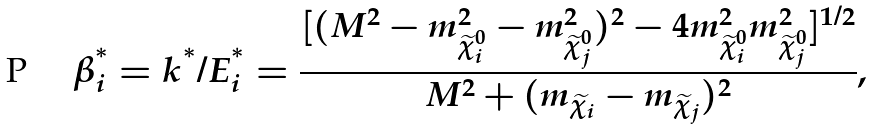<formula> <loc_0><loc_0><loc_500><loc_500>\beta _ { i } ^ { ^ { * } } = { k ^ { ^ { * } } } / { E _ { i } ^ { ^ { * } } } = \frac { [ ( M ^ { 2 } - m _ { \widetilde { \chi } _ { i } ^ { 0 } } ^ { 2 } - m _ { \widetilde { \chi } _ { j } ^ { 0 } } ^ { 2 } ) ^ { 2 } - 4 m _ { \widetilde { \chi } _ { i } ^ { 0 } } ^ { 2 } m _ { \widetilde { \chi } _ { j } ^ { 0 } } ^ { 2 } ] ^ { 1 / 2 } } { M ^ { 2 } + ( m _ { \widetilde { \chi } _ { i } } - m _ { \widetilde { \chi } _ { j } } ) ^ { 2 } } ,</formula> 